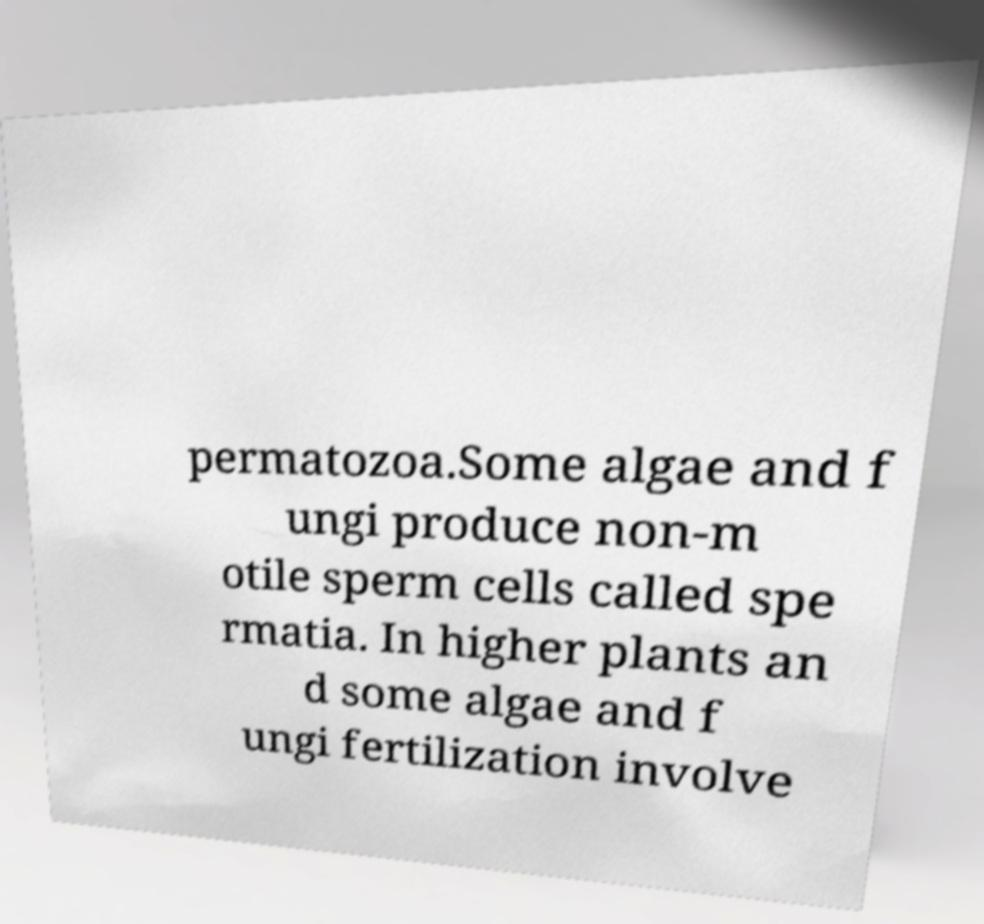Please identify and transcribe the text found in this image. permatozoa.Some algae and f ungi produce non-m otile sperm cells called spe rmatia. In higher plants an d some algae and f ungi fertilization involve 